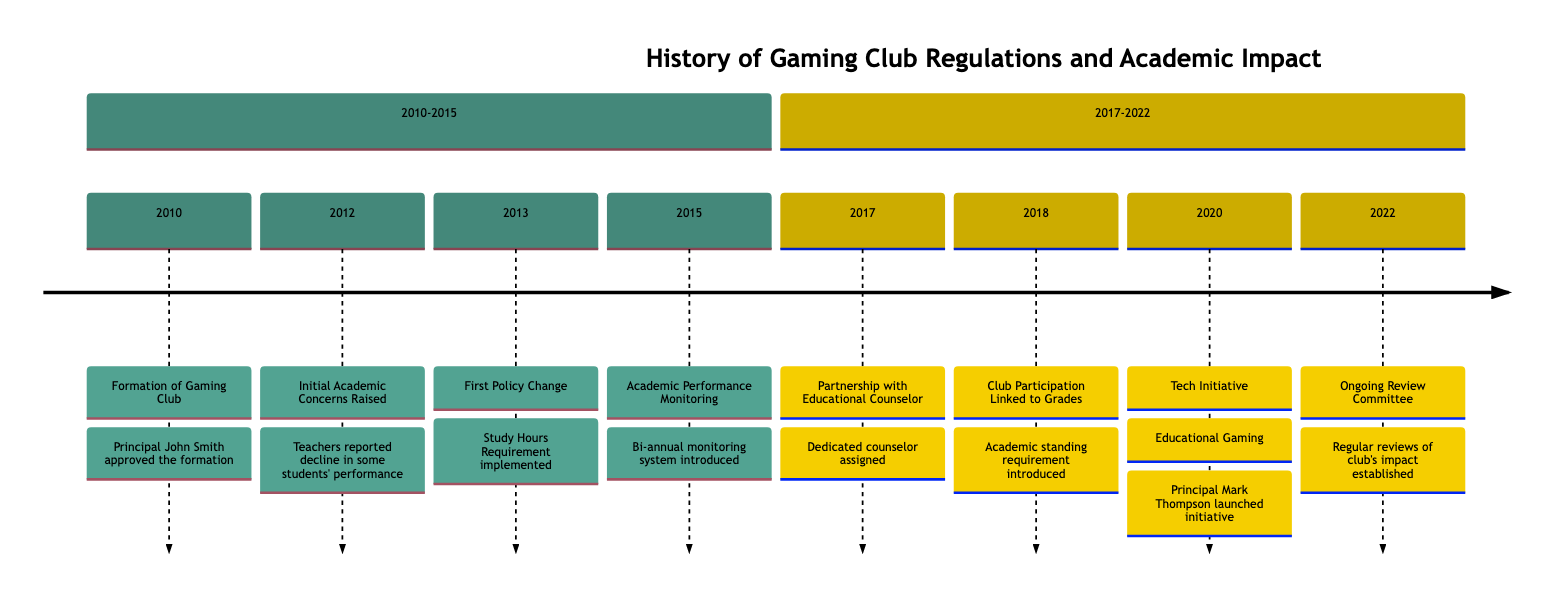What year was the Gaming Club formed? The timeline indicates the event "Formation of Gaming Club" occurred in the year 2010, which is clearly labeled on the diagram.
Answer: 2010 What significant policy was implemented in 2013? The event labeled "First Policy Change: Study Hours Requirement" in the year 2013 indicates the introduction of mandatory study hours for club members.
Answer: Study Hours Requirement How many years passed between the formation of the Gaming Club and the introduction of academic performance monitoring? The Gaming Club was formed in 2010 and academic performance monitoring was introduced in 2015. The difference between these years is calculated as 2015 - 2010 = 5 years.
Answer: 5 What educational initiative was launched in 2020? The timeline shows the event "Tech Initiative: Educational Gaming" in the year 2020, which is the specific initiative mentioned.
Answer: Educational Gaming What requirement was introduced for club participation in 2018? The event labeled "Club Participation Linked to Academic Standing" in 2018 indicates that students were required to meet academic standing criteria to participate in the club.
Answer: Academic Standing Which principal approved the formation of the Gaming Club? The diagram states that "Principal John Smith approved the formation of the Gaming Club," directly attributing the approval to him.
Answer: John Smith What review process was established in 2022? The timeline shows the establishment of an "Ongoing Review Committee," which indicates a committee was formed to regularly review impacts related to the gaming club.
Answer: Ongoing Review Committee How many major policy events are featured in the timeline? By counting the significant events from 2010 to 2022, there are a total of 8 labeled events present in the timeline.
Answer: 8 What role was introduced to support gaming club members in 2017? The timeline mentions "Partnership with Educational Counselor" in 2017, indicating the introduction of a dedicated counselor for gaming club members.
Answer: Educational Counselor 